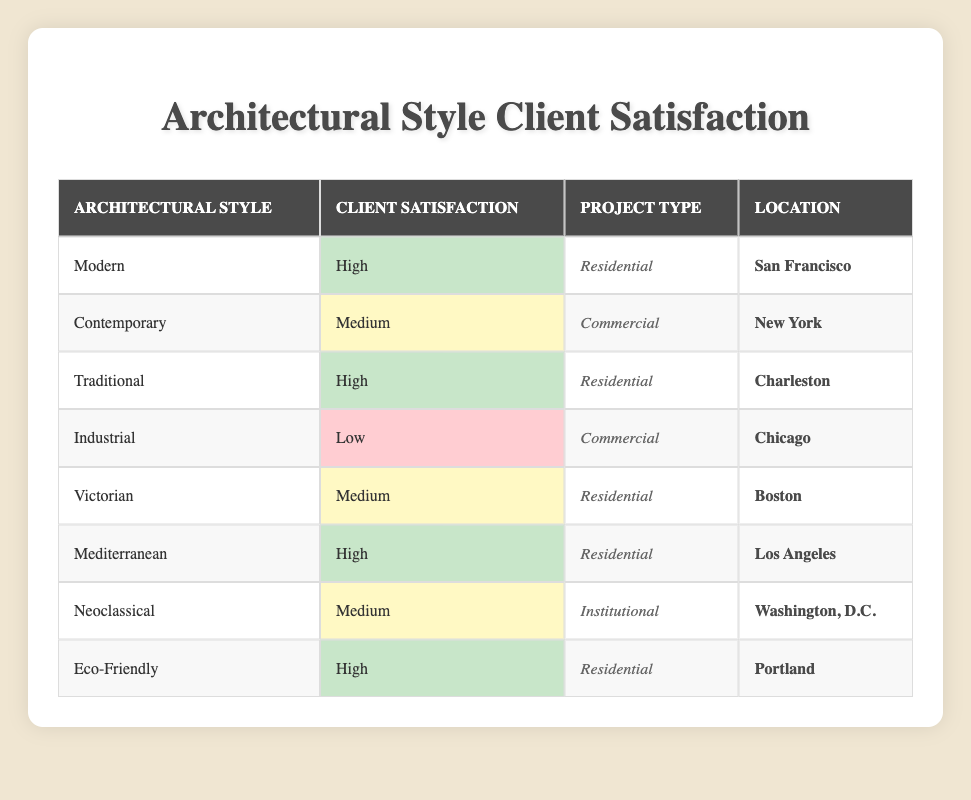What is the client satisfaction level for the Industrial architectural style? Referring to the table, there is one entry for the Industrial architectural style, and its client satisfaction level is categorized as Low.
Answer: Low How many architectural styles have a high client satisfaction level? From the table, the architectural styles with high client satisfaction levels are Modern, Traditional, Mediterranean, and Eco-Friendly. This totals to four architectural styles with high satisfaction.
Answer: 4 Is there any architectural style associated with a Medium satisfaction level that is used for Residential projects? The Victorian architectural style is listed under Residential projects with a Medium satisfaction level. This confirms that there is at least one style that meets this criterion.
Answer: Yes What is the location of the Eco-Friendly architectural style project? According to the table, the Eco-Friendly architectural style project is located in Portland.
Answer: Portland What is the difference in the number of high and low client satisfaction levels? The table shows that there are four architectural styles with high client satisfaction levels (Modern, Traditional, Mediterranean, Eco-Friendly) and one with low (Industrial), so the difference is four minus one, which equals three.
Answer: 3 How many client satisfaction levels are classified as Medium? The architectural styles with a Medium client satisfaction level are Contemporary, Victorian, and Neoclassical, totaling three styles.
Answer: 3 Is the client satisfaction for the Contemporary architectural style higher than that of the Victorian architectural style? The table shows that the Contemporary architectural style has a Medium satisfaction level, while the Victorian architectural style also has a Medium satisfaction level. Therefore, they are not different, as both are rated the same.
Answer: No Which architectural style with a High client satisfaction level is associated with the location of San Francisco? The table indicates that the Modern architectural style is associated with a High client satisfaction level in San Francisco.
Answer: Modern 